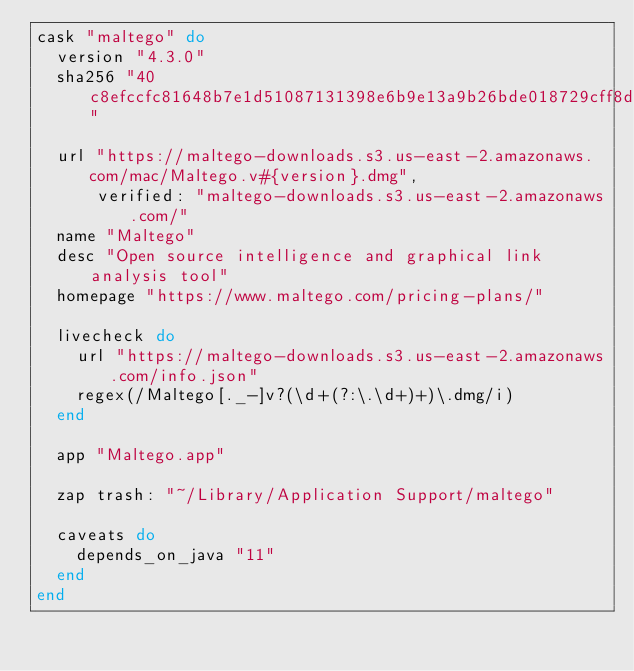Convert code to text. <code><loc_0><loc_0><loc_500><loc_500><_Ruby_>cask "maltego" do
  version "4.3.0"
  sha256 "40c8efccfc81648b7e1d51087131398e6b9e13a9b26bde018729cff8dd4a51dd"

  url "https://maltego-downloads.s3.us-east-2.amazonaws.com/mac/Maltego.v#{version}.dmg",
      verified: "maltego-downloads.s3.us-east-2.amazonaws.com/"
  name "Maltego"
  desc "Open source intelligence and graphical link analysis tool"
  homepage "https://www.maltego.com/pricing-plans/"

  livecheck do
    url "https://maltego-downloads.s3.us-east-2.amazonaws.com/info.json"
    regex(/Maltego[._-]v?(\d+(?:\.\d+)+)\.dmg/i)
  end

  app "Maltego.app"

  zap trash: "~/Library/Application Support/maltego"

  caveats do
    depends_on_java "11"
  end
end
</code> 